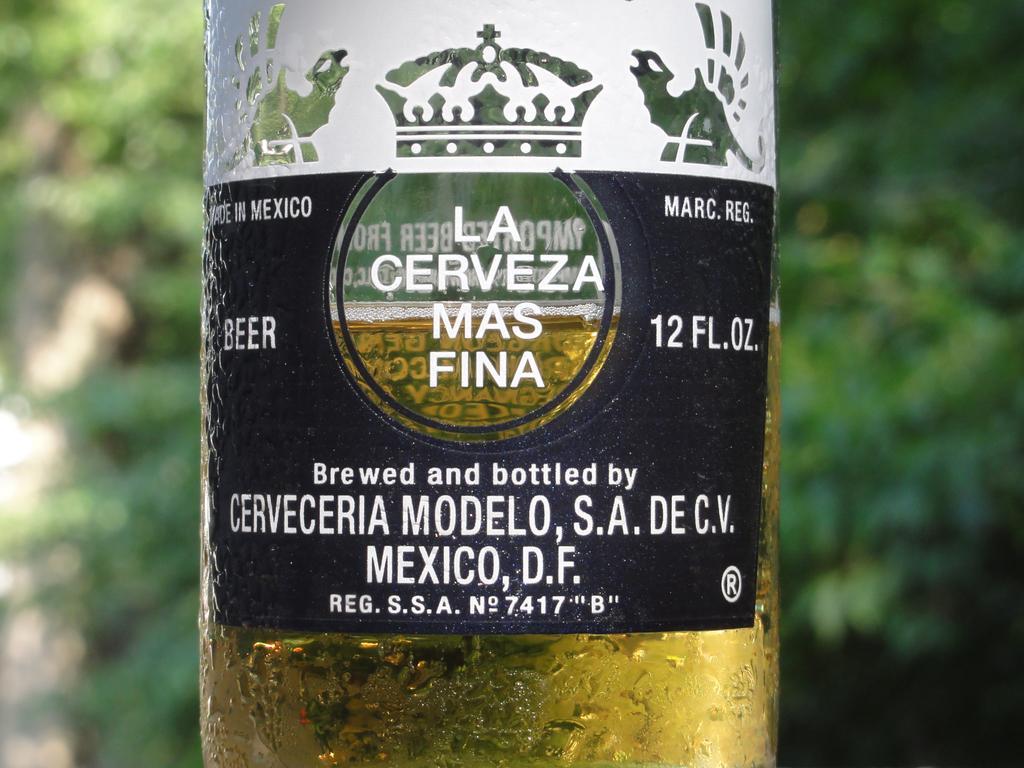Can you describe this image briefly? This image is clicked outside, there is a beer bottle. And a sticker is pasted on it. It is written as 'cerveceria modelo S. A DE. CV'. 